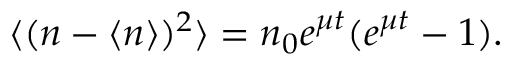<formula> <loc_0><loc_0><loc_500><loc_500>\langle ( n - \langle n \rangle ) ^ { 2 } \rangle = n _ { 0 } e ^ { \mu t } ( e ^ { \mu t } - 1 ) .</formula> 